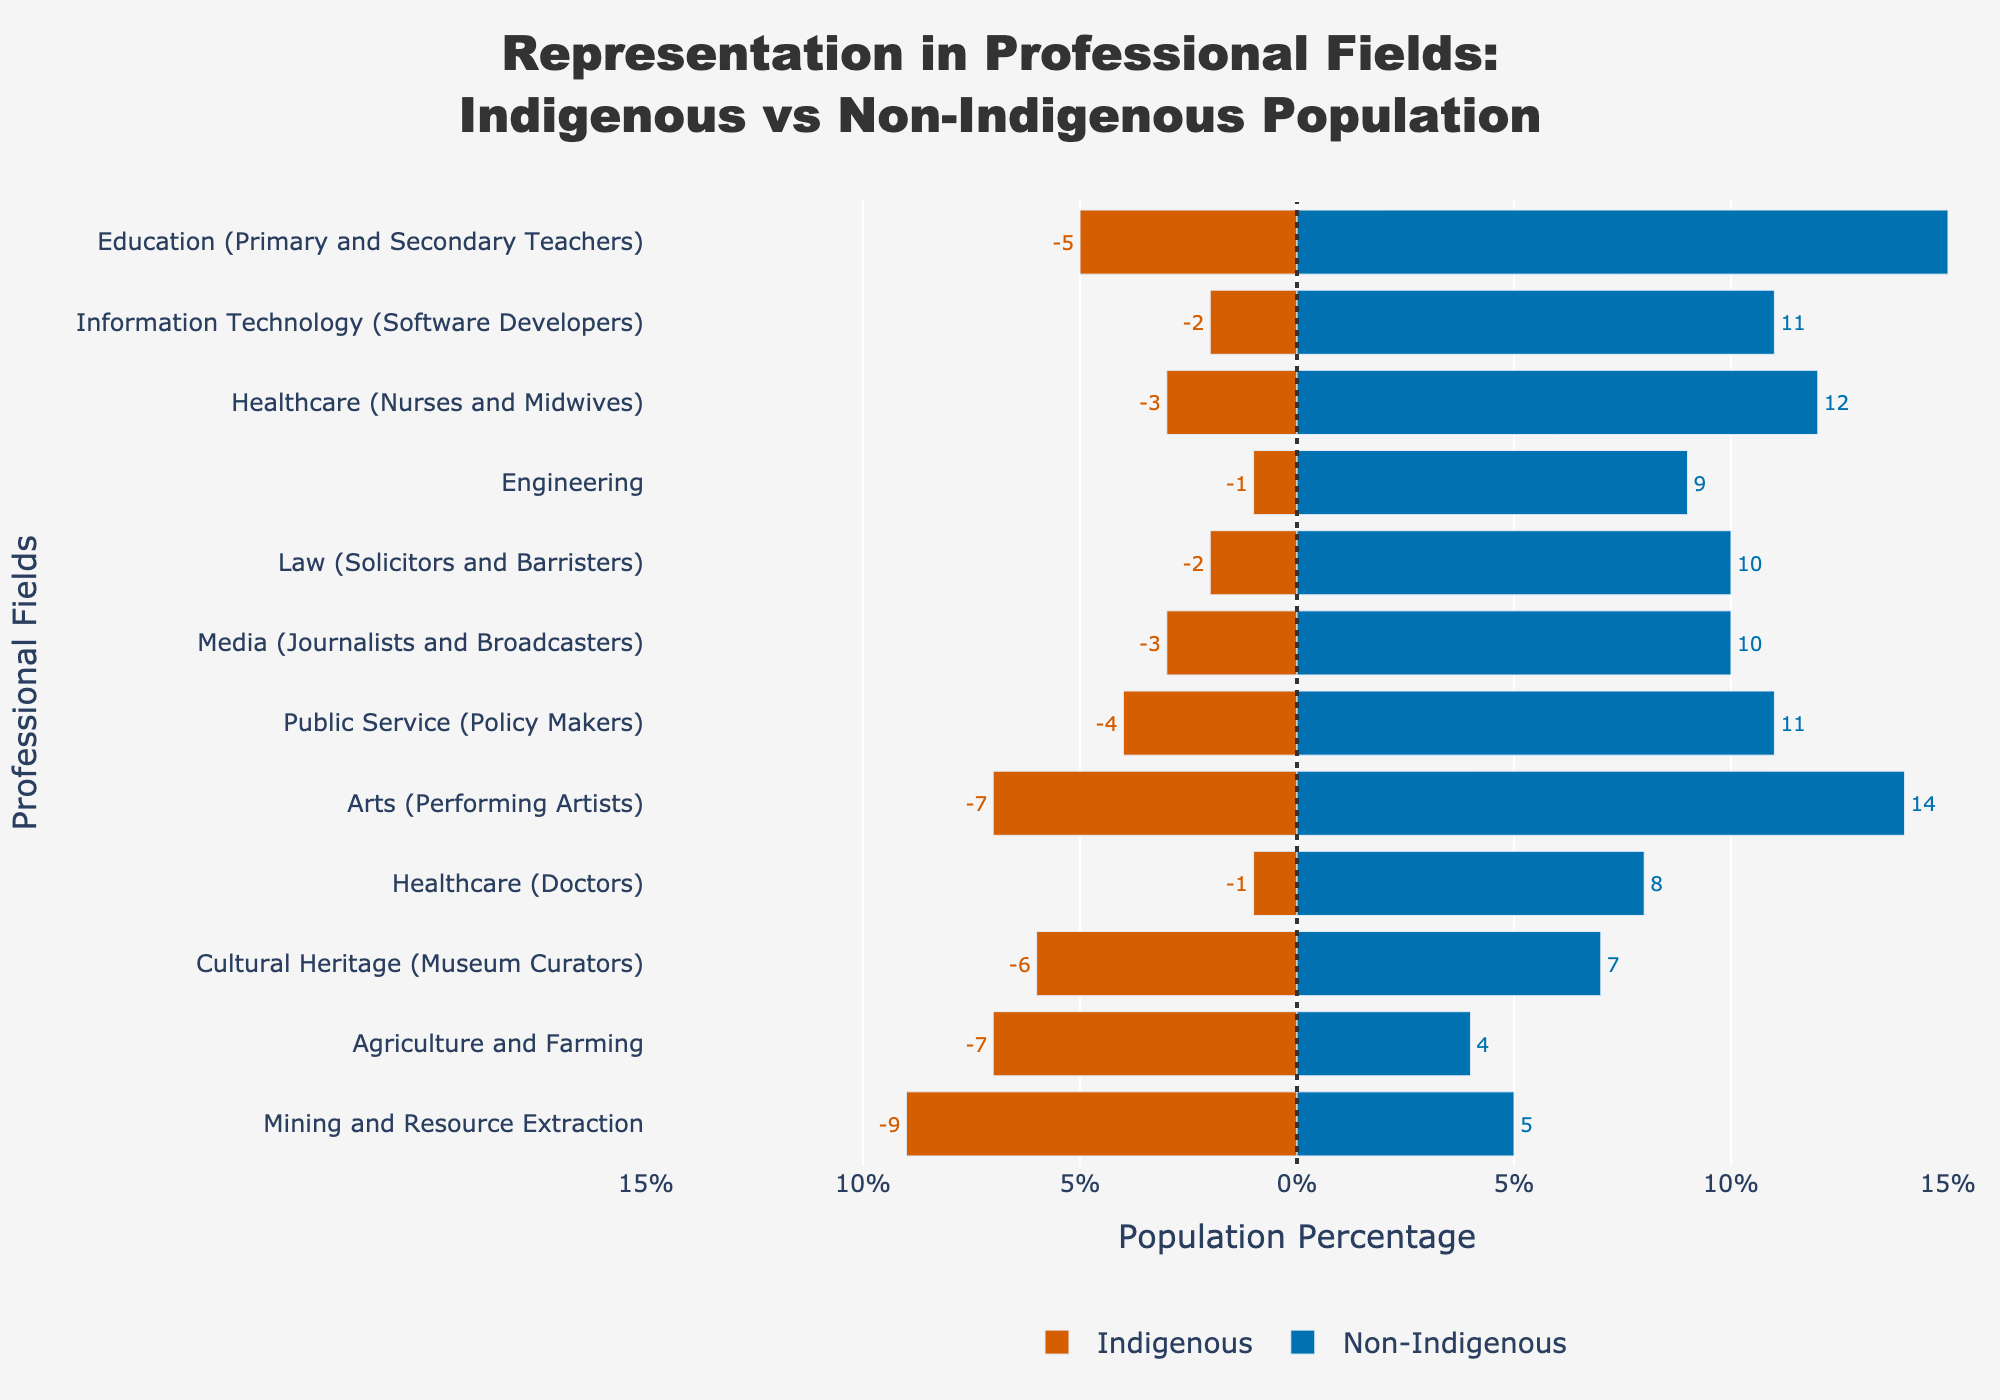Which professional field has the highest representation of the Indigenous population? The Mining and Resource Extraction field has the highest representation of the Indigenous population, as shown by the longest red bar on the indigenous side.
Answer: Mining and Resource Extraction What is the difference in representation between Indigenous and Non-Indigenous populations in the Healthcare (Doctors) field? The Indigenous population is at 1%, and the Non-Indigenous is at 8%. The difference is 8% - 1%.
Answer: 7% Which field shows a higher percentage of Indigenous population compared to Non-Indigenous population? The Agriculture and Farming field shows a higher percentage of the Indigenous population at 7% compared to the Non-Indigenous population at 4%, as indicated by the longer red bar than the blue bar on the positive side.
Answer: Agriculture and Farming In which field is the representation of Indigenous people closest to that of Non-Indigenous people? The Cultural Heritage (Museum Curators) field shows Indigenous representation at 6% and Non-Indigenous at 7%. The difference here (1%) is the smallest among all fields.
Answer: Cultural Heritage (Museum Curators) Which two fields have the largest absolute difference in representation between Indigenous and Non-Indigenous populations? Education (Primary and Secondary Teachers) and Healthcare (Nurses and Midwives) have the largest absolute differences as their representations are 5% vs. 15% and 3% vs. 12%, respectively. Both have a 10% difference.
Answer: Education (Primary and Secondary Teachers), Healthcare (Nurses and Midwives) What is the total percentage representation of both Indigenous and Non-Indigenous populations in the Media (Journalists and Broadcasters) field? The Indigenous population in this field is 3%, and the Non-Indigenous population is 10%. Sum them up: 3% + 10%.
Answer: 13% Which field has the highest representation of Non-Indigenous population? The Education (Primary and Secondary Teachers) field has the highest representation of the Non-Indigenous population at 15%, as indicated by the longest blue bar.
Answer: Education (Primary and Secondary Teachers) How does the representation of Indigenous populations in the Nursing field compare to that in the Law field? The Indigenous representation in Healthcare (Nurses and Midwives) is 3%, while it is 2% in Law (Solicitors and Barristers). 3% is greater than 2%.
Answer: Healthcare (Nurses and Midwives) What is the average representation of the Indigenous population in all fields? Sum the percentages of Indigenous populations across all fields: 5 + 3 + 1 + 2 + 1 + 2 + 7 + 4 + 6 + 3 + 9 + 7 = 50. There are 12 fields, so the average is 50/12.
Answer: ~4.17% 